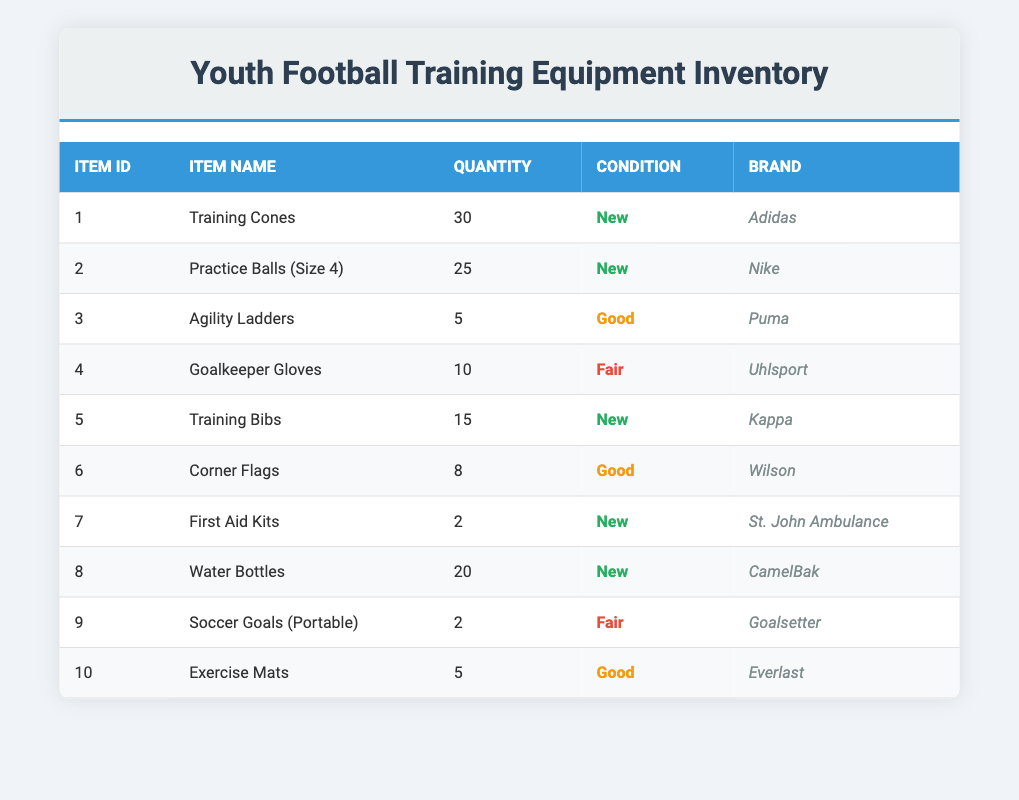What is the quantity of Training Cones? The table lists the item "Training Cones" under the item name column. The quantity for this item is 30 as shown in the quantity column.
Answer: 30 Which brand supplies the Practice Balls? Looking in the table, the item "Practice Balls (Size 4)" indicates the brand as "Nike." This is found under the brand column corresponding to that item.
Answer: Nike How many items are in Fair condition? The table lists three items in Fair condition: Goalkeeper Gloves and Soccer Goals (Portable). Counting these gives us a total of 2 items.
Answer: 2 What is the total number of water bottles and training bibs available? First, find the quantity of water bottles (20) and training bibs (15) in the respective rows. Then add them: 20 + 15 = 35.
Answer: 35 Are there more training bibs than agility ladders? The quantity of training bibs is 15, while the quantity of agility ladders is 5. Since 15 is greater than 5, the statement is true.
Answer: Yes What percentage of the inventory items are in New condition? There are 6 items listed as New out of a total of 10 items. To find the percentage, divide 6 by 10, then multiply by 100, giving us 60%.
Answer: 60% What are the two items that are in Fair condition and their quantities? By examining the table, the items in Fair condition are: Goalkeeper Gloves with a quantity of 10, and Soccer Goals (Portable) with a quantity of 2.
Answer: Goalkeeper Gloves (10), Soccer Goals (2) Which brand has the most equipment in the inventory? To determine the brand with the most equipment, we need to analyze the quantities: Adidas (30), Nike (25), Puma (5), Uhlsport (10), Kappa (15), Wilson (8), St. John Ambulance (2), CamelBak (20), Goalsetter (2), Everlast (5). Therefore, Adidas has the highest quantity with 30 items.
Answer: Adidas How many more First Aid Kits are there than Soccer Goals (Portable)? First, analyze the quantities: First Aid Kits (2) and Soccer Goals (Portable) (2). The difference is 2 - 2 = 0, indicating they are equal.
Answer: 0 